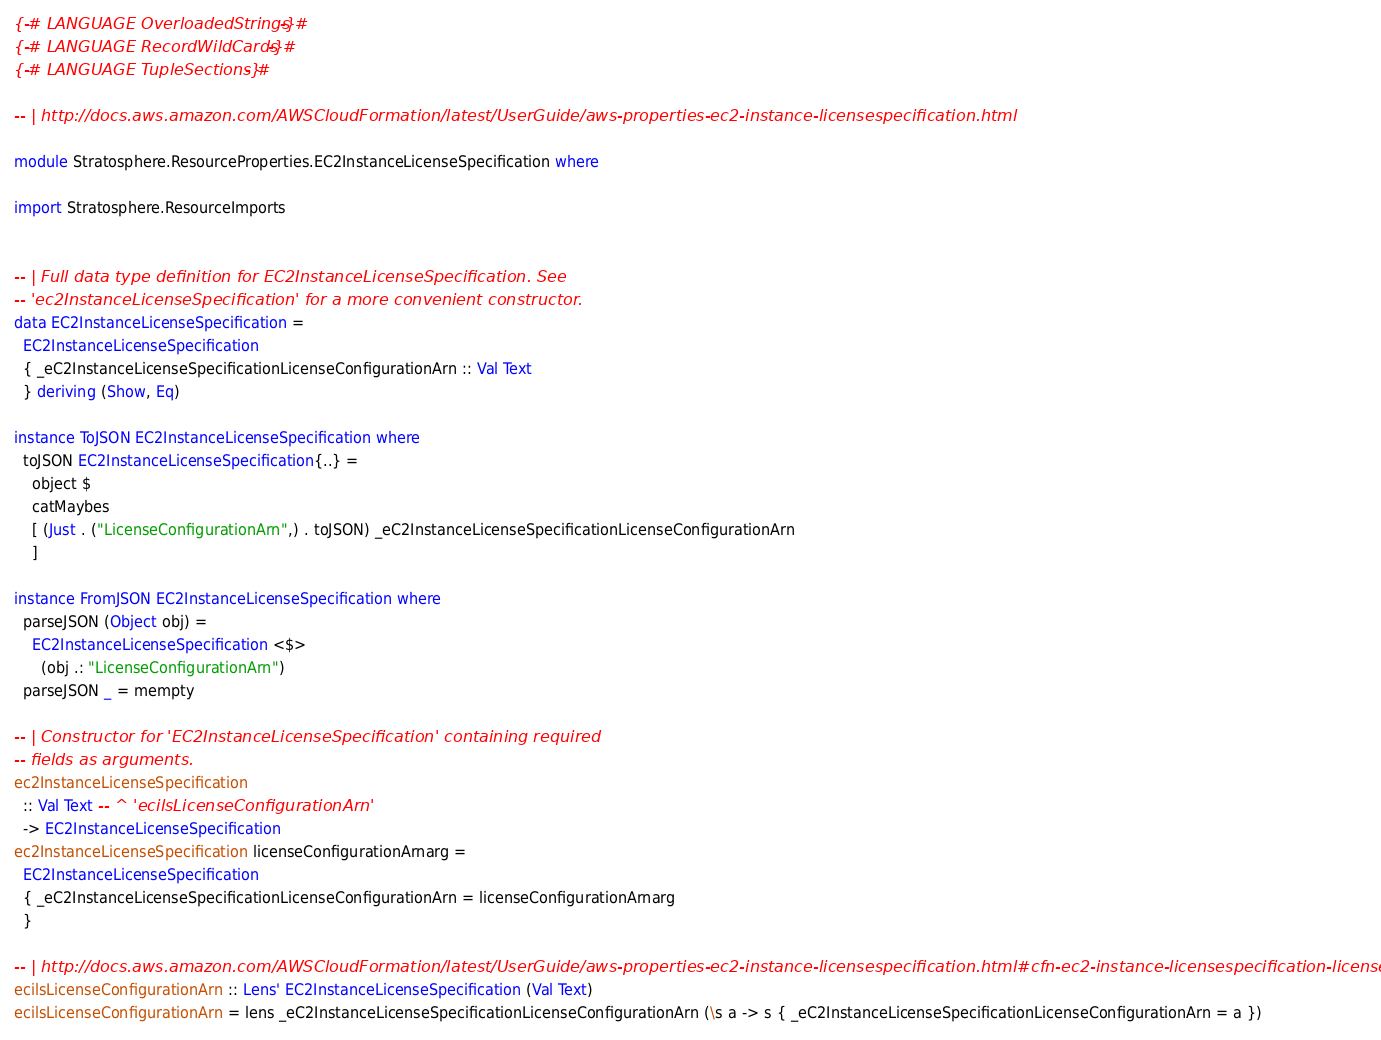Convert code to text. <code><loc_0><loc_0><loc_500><loc_500><_Haskell_>{-# LANGUAGE OverloadedStrings #-}
{-# LANGUAGE RecordWildCards #-}
{-# LANGUAGE TupleSections #-}

-- | http://docs.aws.amazon.com/AWSCloudFormation/latest/UserGuide/aws-properties-ec2-instance-licensespecification.html

module Stratosphere.ResourceProperties.EC2InstanceLicenseSpecification where

import Stratosphere.ResourceImports


-- | Full data type definition for EC2InstanceLicenseSpecification. See
-- 'ec2InstanceLicenseSpecification' for a more convenient constructor.
data EC2InstanceLicenseSpecification =
  EC2InstanceLicenseSpecification
  { _eC2InstanceLicenseSpecificationLicenseConfigurationArn :: Val Text
  } deriving (Show, Eq)

instance ToJSON EC2InstanceLicenseSpecification where
  toJSON EC2InstanceLicenseSpecification{..} =
    object $
    catMaybes
    [ (Just . ("LicenseConfigurationArn",) . toJSON) _eC2InstanceLicenseSpecificationLicenseConfigurationArn
    ]

instance FromJSON EC2InstanceLicenseSpecification where
  parseJSON (Object obj) =
    EC2InstanceLicenseSpecification <$>
      (obj .: "LicenseConfigurationArn")
  parseJSON _ = mempty

-- | Constructor for 'EC2InstanceLicenseSpecification' containing required
-- fields as arguments.
ec2InstanceLicenseSpecification
  :: Val Text -- ^ 'ecilsLicenseConfigurationArn'
  -> EC2InstanceLicenseSpecification
ec2InstanceLicenseSpecification licenseConfigurationArnarg =
  EC2InstanceLicenseSpecification
  { _eC2InstanceLicenseSpecificationLicenseConfigurationArn = licenseConfigurationArnarg
  }

-- | http://docs.aws.amazon.com/AWSCloudFormation/latest/UserGuide/aws-properties-ec2-instance-licensespecification.html#cfn-ec2-instance-licensespecification-licenseconfigurationarn
ecilsLicenseConfigurationArn :: Lens' EC2InstanceLicenseSpecification (Val Text)
ecilsLicenseConfigurationArn = lens _eC2InstanceLicenseSpecificationLicenseConfigurationArn (\s a -> s { _eC2InstanceLicenseSpecificationLicenseConfigurationArn = a })
</code> 